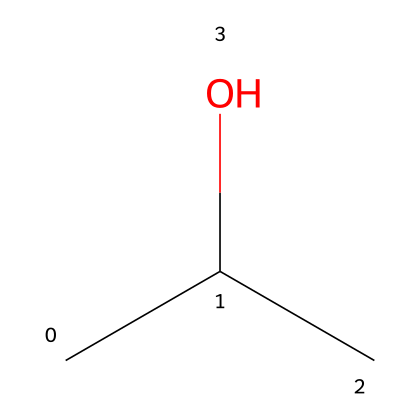What is the name of this chemical? The SMILES representation CC(C)O corresponds to isopropyl alcohol, as it indicates the presence of a carbon structure with a hydroxyl group (-OH) attached to it which defines alcohols.
Answer: isopropyl alcohol How many carbon atoms are in isopropyl alcohol? The SMILES CC(C)O reveals that there are three carbons (C) in the structure, as indicated by the three 'C's present before and around the parentheses.
Answer: 3 What functional group is present in isopropyl alcohol? The '-OH' group attached to the carbon structure represents a hydroxyl group, which is the defining feature of alcohols, including isopropyl alcohol.
Answer: hydroxyl group What is the molecular formula of isopropyl alcohol? By analyzing the SMILES CC(C)O, we count three carbon (C) atoms, eight hydrogen (H) atoms, and one oxygen (O) atom, giving the formula C3H8O.
Answer: C3H8O Is isopropyl alcohol a polar or nonpolar solvent? The presence of the hydroxyl group makes isopropyl alcohol polar, as the -OH group can form hydrogen bonds, impacting its solubility in water.
Answer: polar What is the significance of the branching in isopropyl alcohol? The branching indicated by the parentheses (C) and the arrangement of the carbon atoms affects its boiling point and polarity, making it effective as a solvent in various applications.
Answer: affects properties How many hydrogen atoms are bonded to each carbon atom in isopropyl alcohol? In the structure, the first carbon (attached to -OH) has one hydrogen, the second carbon has one hydrogen, and the third carbon has three hydrogens, resulting in a total of eight.
Answer: 8 